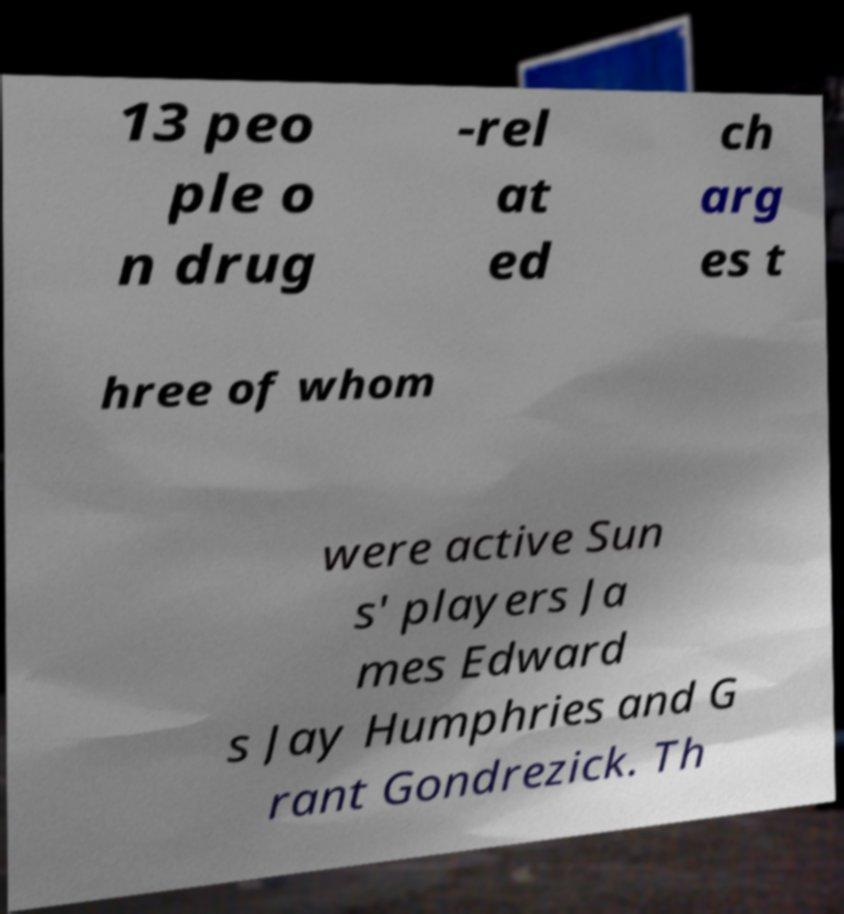Could you assist in decoding the text presented in this image and type it out clearly? 13 peo ple o n drug -rel at ed ch arg es t hree of whom were active Sun s' players Ja mes Edward s Jay Humphries and G rant Gondrezick. Th 